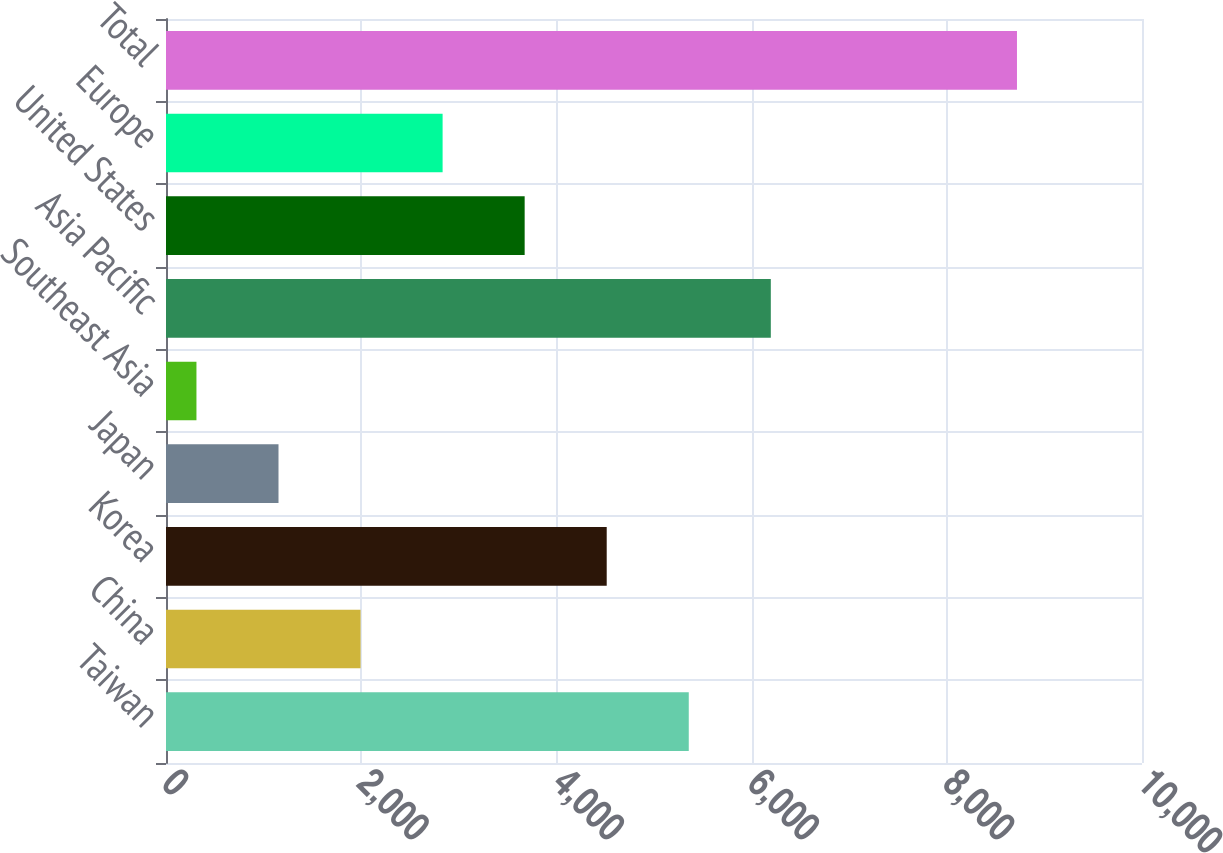Convert chart. <chart><loc_0><loc_0><loc_500><loc_500><bar_chart><fcel>Taiwan<fcel>China<fcel>Korea<fcel>Japan<fcel>Southeast Asia<fcel>Asia Pacific<fcel>United States<fcel>Europe<fcel>Total<nl><fcel>5356.2<fcel>1993.4<fcel>4515.5<fcel>1152.7<fcel>312<fcel>6196.9<fcel>3674.8<fcel>2834.1<fcel>8719<nl></chart> 